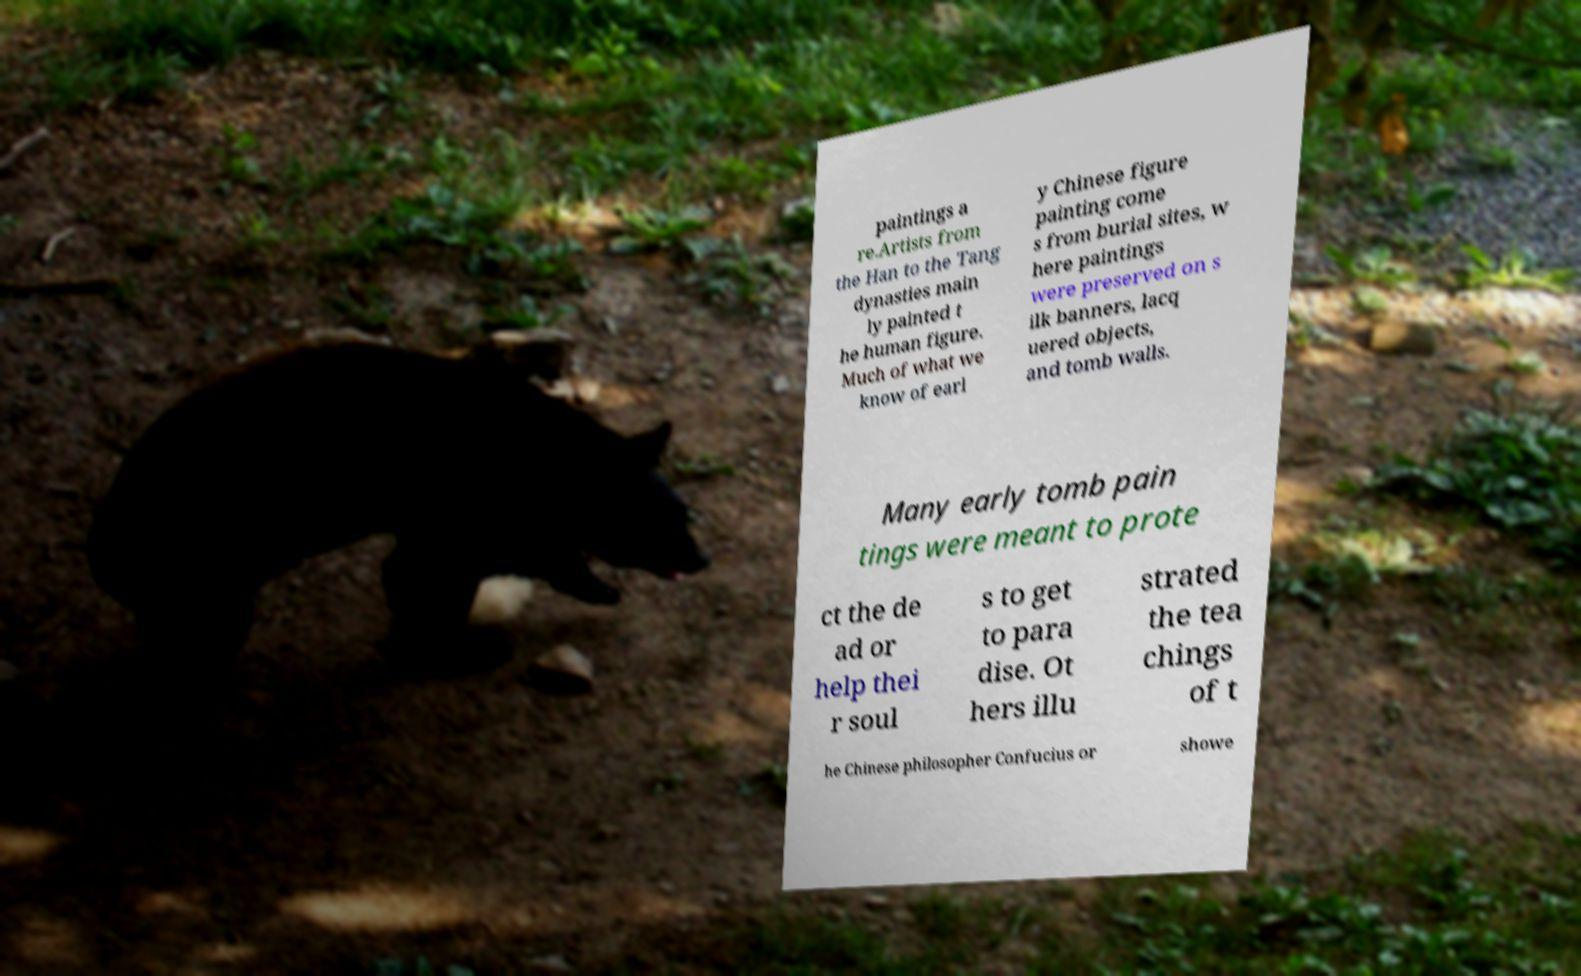I need the written content from this picture converted into text. Can you do that? paintings a re.Artists from the Han to the Tang dynasties main ly painted t he human figure. Much of what we know of earl y Chinese figure painting come s from burial sites, w here paintings were preserved on s ilk banners, lacq uered objects, and tomb walls. Many early tomb pain tings were meant to prote ct the de ad or help thei r soul s to get to para dise. Ot hers illu strated the tea chings of t he Chinese philosopher Confucius or showe 